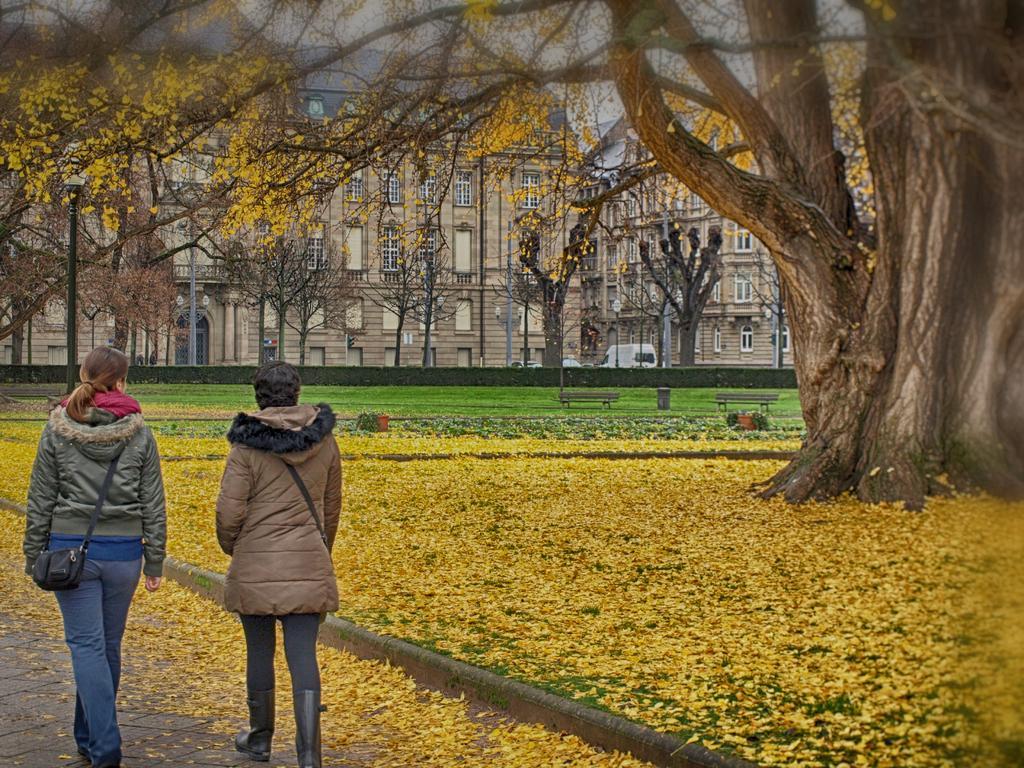Describe this image in one or two sentences. In this picture,this are two women on the left side. And this is a big tree. 